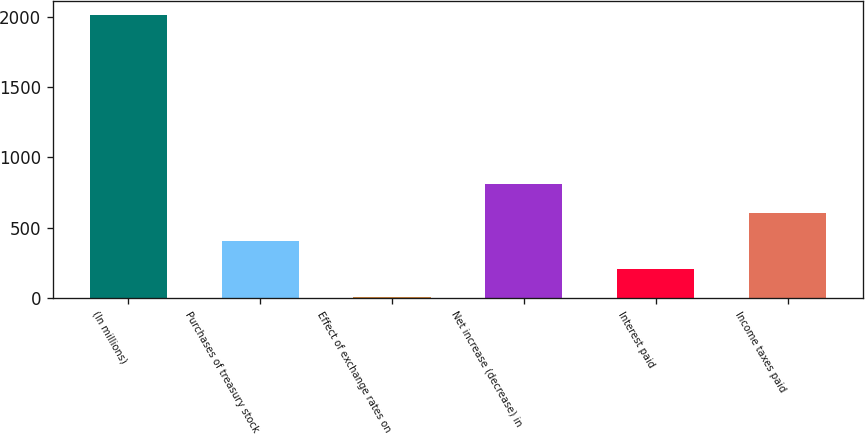Convert chart to OTSL. <chart><loc_0><loc_0><loc_500><loc_500><bar_chart><fcel>(In millions)<fcel>Purchases of treasury stock<fcel>Effect of exchange rates on<fcel>Net increase (decrease) in<fcel>Interest paid<fcel>Income taxes paid<nl><fcel>2013<fcel>405<fcel>3<fcel>807<fcel>204<fcel>606<nl></chart> 